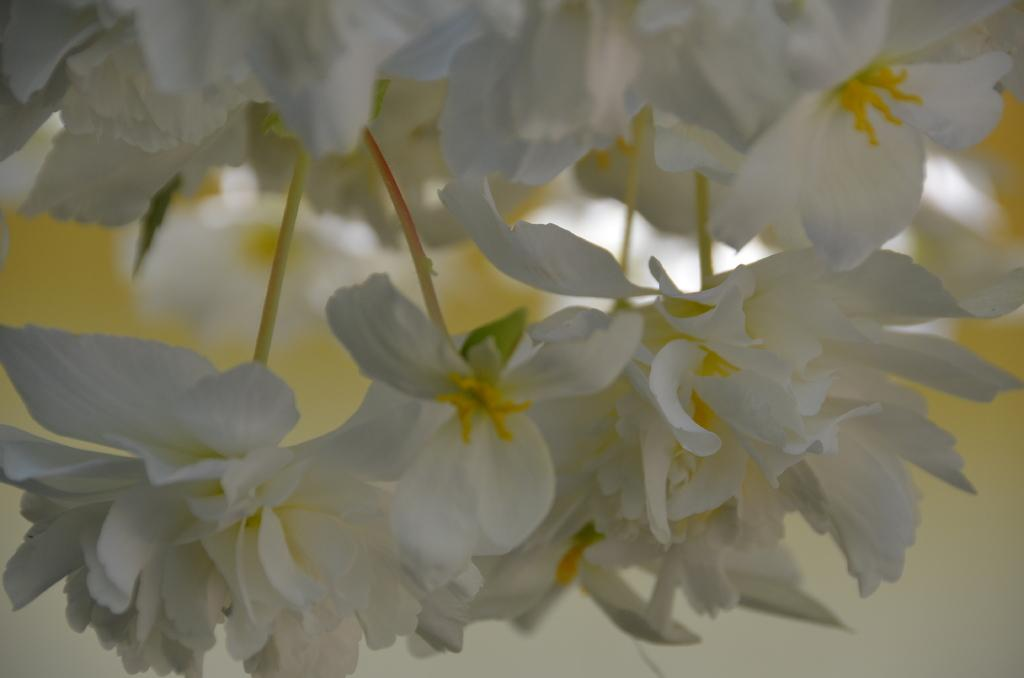What type of flowers can be seen in the image? There are white flowers in the image. What parts of the flowers are visible in the image? There are stems and leaves visible in the image. How would you describe the background of the image? The background of the image has a blurred view. Can you see the ocean in the background of the image? No, there is no ocean visible in the image. 